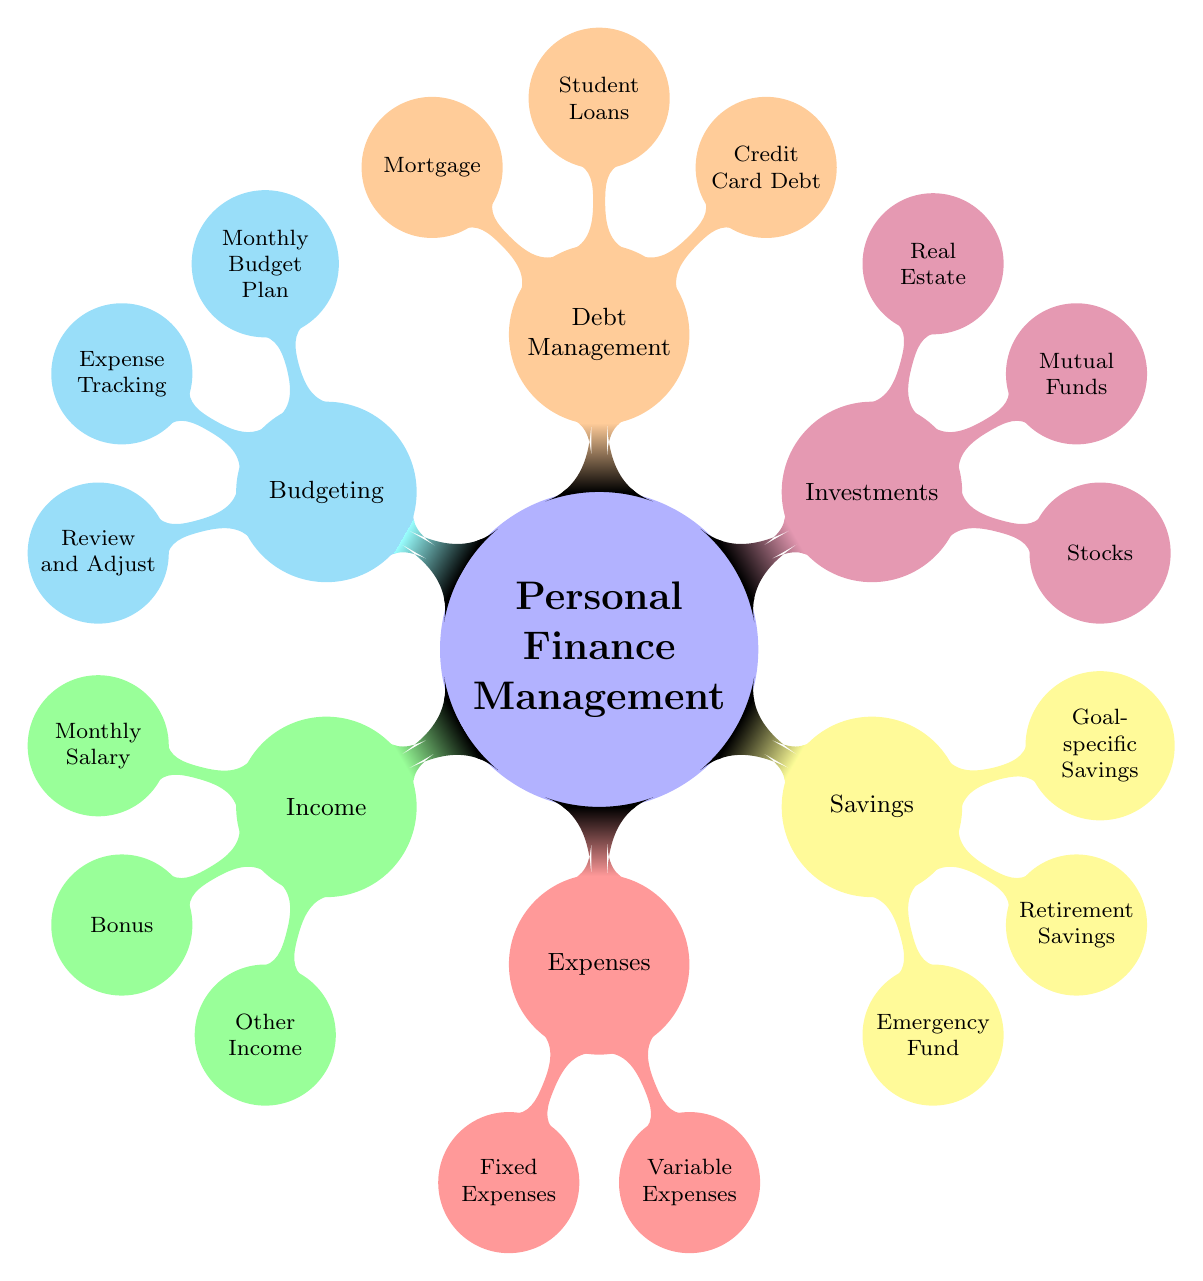What are the three categories under Personal Finance Management? The diagram shows the main category "Personal Finance Management" and branches out into five child nodes: Income, Expenses, Savings, Investments, Debt Management, and Budgeting. Therefore, the three categories are: "Income", "Expenses", and "Savings".
Answer: Income, Expenses, Savings How many types of savings are listed? Within the "Savings" node, there are three sub-nodes: Emergency Fund, Retirement Savings, and Goal-specific Savings. Counting these three, there are three types of savings listed.
Answer: Three What is a fixed expense mentioned in the diagram? The "Expenses" category branches into "Fixed Expenses", which then further lists multiple items. One example of a fixed expense is "Rent or Mortgage".
Answer: Rent or Mortgage Which type of investment includes real estate? The "Investments" category lists three types, and "Real Estate" is one of these. Therefore, this question is asking for the specific investment type mentioned that includes real estate investments.
Answer: Real Estate How is the total budget tracked according to the diagram? In the "Budgeting" category, it mentions "Expense Tracking". This suggests that tracking expenses is a method used to monitor budgeting.
Answer: Expense Tracking What type of income is represented by bonus? Under the "Income" category, one of the sub-nodes is labeled "Bonus". This indicates that incentive-based earnings are classified as bonus income.
Answer: Performance-based Incentives Which area focuses on managing credit card debt? The node "Debt Management" specifically covers different debts, including "Credit Card Debt", indicating that this area is focused on managing credit card responsibilities.
Answer: Credit Card Debt What do goal-specific savings include? Within the "Savings" node, the sub-category "Goal-specific Savings" branches into "Vacation Fund" and "Down Payment". This identifies what goal-specific savings include.
Answer: Vacation Fund and Down Payment 